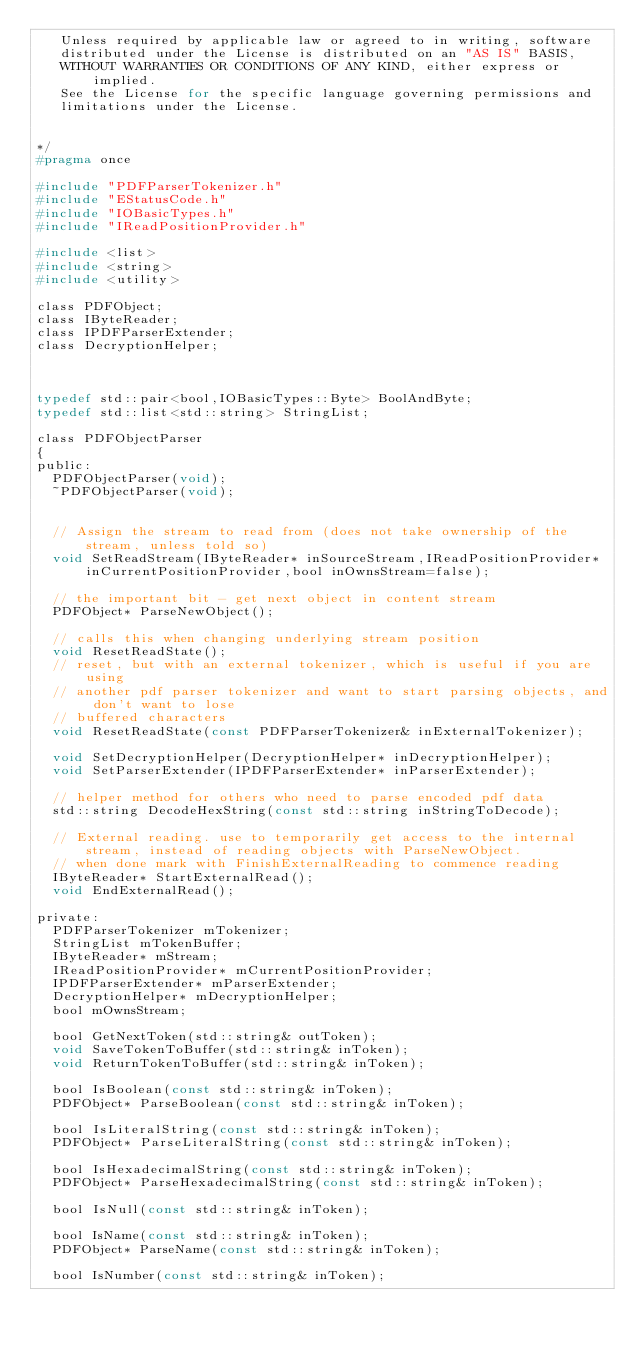<code> <loc_0><loc_0><loc_500><loc_500><_C_>   Unless required by applicable law or agreed to in writing, software
   distributed under the License is distributed on an "AS IS" BASIS,
   WITHOUT WARRANTIES OR CONDITIONS OF ANY KIND, either express or implied.
   See the License for the specific language governing permissions and
   limitations under the License.

   
*/
#pragma once

#include "PDFParserTokenizer.h"
#include "EStatusCode.h"
#include "IOBasicTypes.h"
#include "IReadPositionProvider.h"

#include <list>
#include <string>
#include <utility>

class PDFObject;
class IByteReader;
class IPDFParserExtender;
class DecryptionHelper;



typedef std::pair<bool,IOBasicTypes::Byte> BoolAndByte;
typedef std::list<std::string> StringList;

class PDFObjectParser
{
public:
	PDFObjectParser(void);
	~PDFObjectParser(void);

	
	// Assign the stream to read from (does not take ownership of the stream, unless told so)
	void SetReadStream(IByteReader* inSourceStream,IReadPositionProvider* inCurrentPositionProvider,bool inOwnsStream=false);

	// the important bit - get next object in content stream
	PDFObject* ParseNewObject();

	// calls this when changing underlying stream position
	void ResetReadState();
	// reset, but with an external tokenizer, which is useful if you are using
	// another pdf parser tokenizer and want to start parsing objects, and don't want to lose
	// buffered characters
	void ResetReadState(const PDFParserTokenizer& inExternalTokenizer);

	void SetDecryptionHelper(DecryptionHelper* inDecryptionHelper);
	void SetParserExtender(IPDFParserExtender* inParserExtender);

	// helper method for others who need to parse encoded pdf data
	std::string DecodeHexString(const std::string inStringToDecode);

	// External reading. use to temporarily get access to the internal stream, instead of reading objects with ParseNewObject.
	// when done mark with FinishExternalReading to commence reading
	IByteReader* StartExternalRead();
	void EndExternalRead();

private:
	PDFParserTokenizer mTokenizer;
	StringList mTokenBuffer;
	IByteReader* mStream;
	IReadPositionProvider* mCurrentPositionProvider;
	IPDFParserExtender* mParserExtender;
	DecryptionHelper* mDecryptionHelper;
	bool mOwnsStream;

	bool GetNextToken(std::string& outToken);
	void SaveTokenToBuffer(std::string& inToken);
	void ReturnTokenToBuffer(std::string& inToken);

	bool IsBoolean(const std::string& inToken);
	PDFObject* ParseBoolean(const std::string& inToken);

	bool IsLiteralString(const std::string& inToken);
	PDFObject* ParseLiteralString(const std::string& inToken);

	bool IsHexadecimalString(const std::string& inToken);
	PDFObject* ParseHexadecimalString(const std::string& inToken);

	bool IsNull(const std::string& inToken);

	bool IsName(const std::string& inToken);
	PDFObject* ParseName(const std::string& inToken);

	bool IsNumber(const std::string& inToken);</code> 